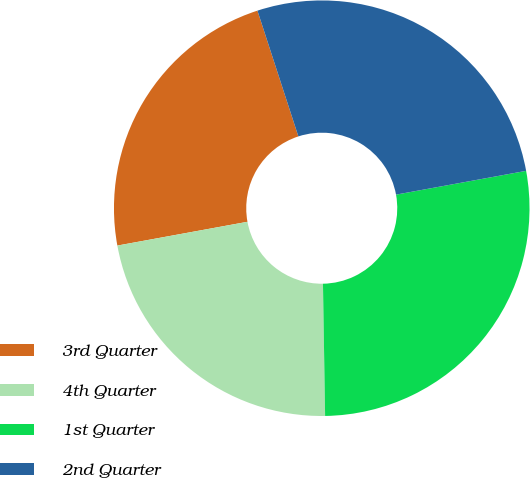<chart> <loc_0><loc_0><loc_500><loc_500><pie_chart><fcel>3rd Quarter<fcel>4th Quarter<fcel>1st Quarter<fcel>2nd Quarter<nl><fcel>22.87%<fcel>22.38%<fcel>27.62%<fcel>27.13%<nl></chart> 